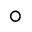<formula> <loc_0><loc_0><loc_500><loc_500>^ { \circ }</formula> 